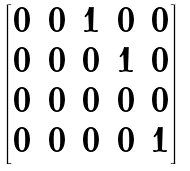<formula> <loc_0><loc_0><loc_500><loc_500>\begin{bmatrix} 0 & 0 & 1 & 0 & 0 \\ 0 & 0 & 0 & 1 & 0 \\ 0 & 0 & 0 & 0 & 0 \\ 0 & 0 & 0 & 0 & 1 \end{bmatrix}</formula> 